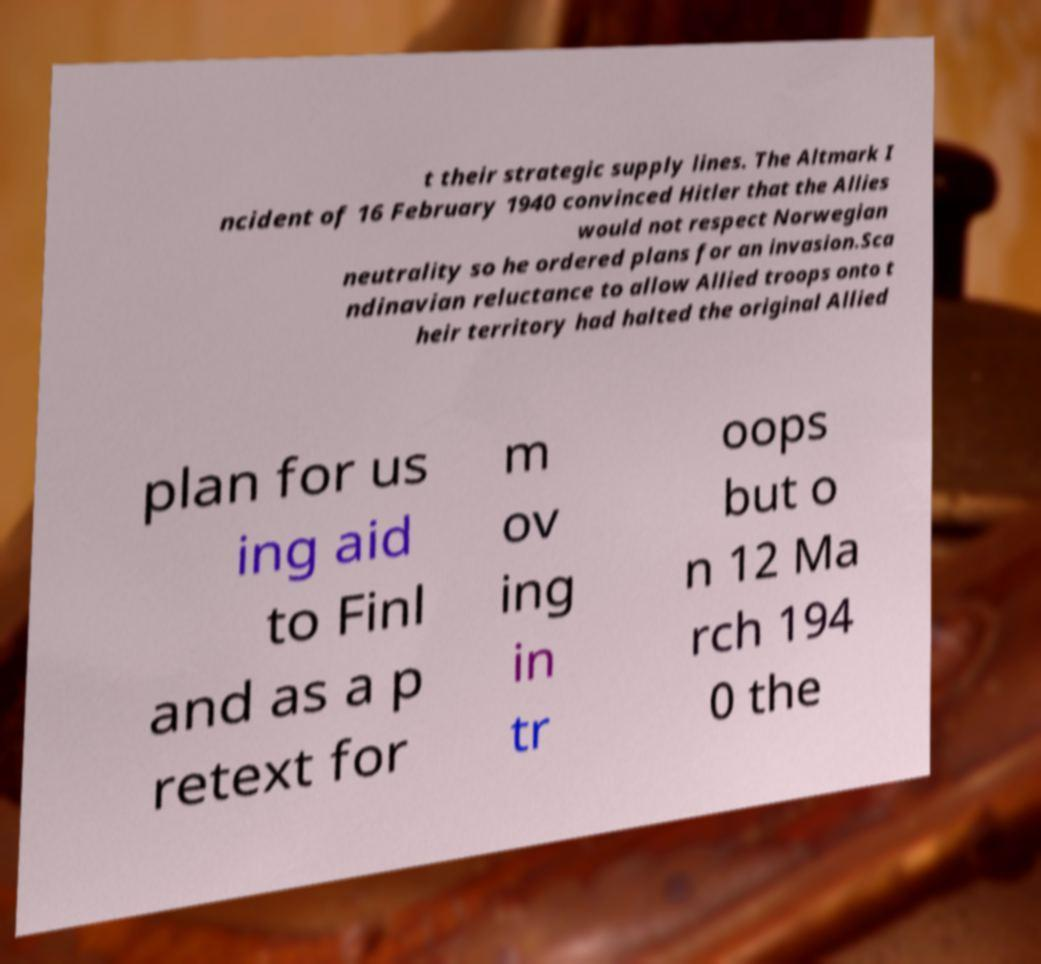There's text embedded in this image that I need extracted. Can you transcribe it verbatim? t their strategic supply lines. The Altmark I ncident of 16 February 1940 convinced Hitler that the Allies would not respect Norwegian neutrality so he ordered plans for an invasion.Sca ndinavian reluctance to allow Allied troops onto t heir territory had halted the original Allied plan for us ing aid to Finl and as a p retext for m ov ing in tr oops but o n 12 Ma rch 194 0 the 